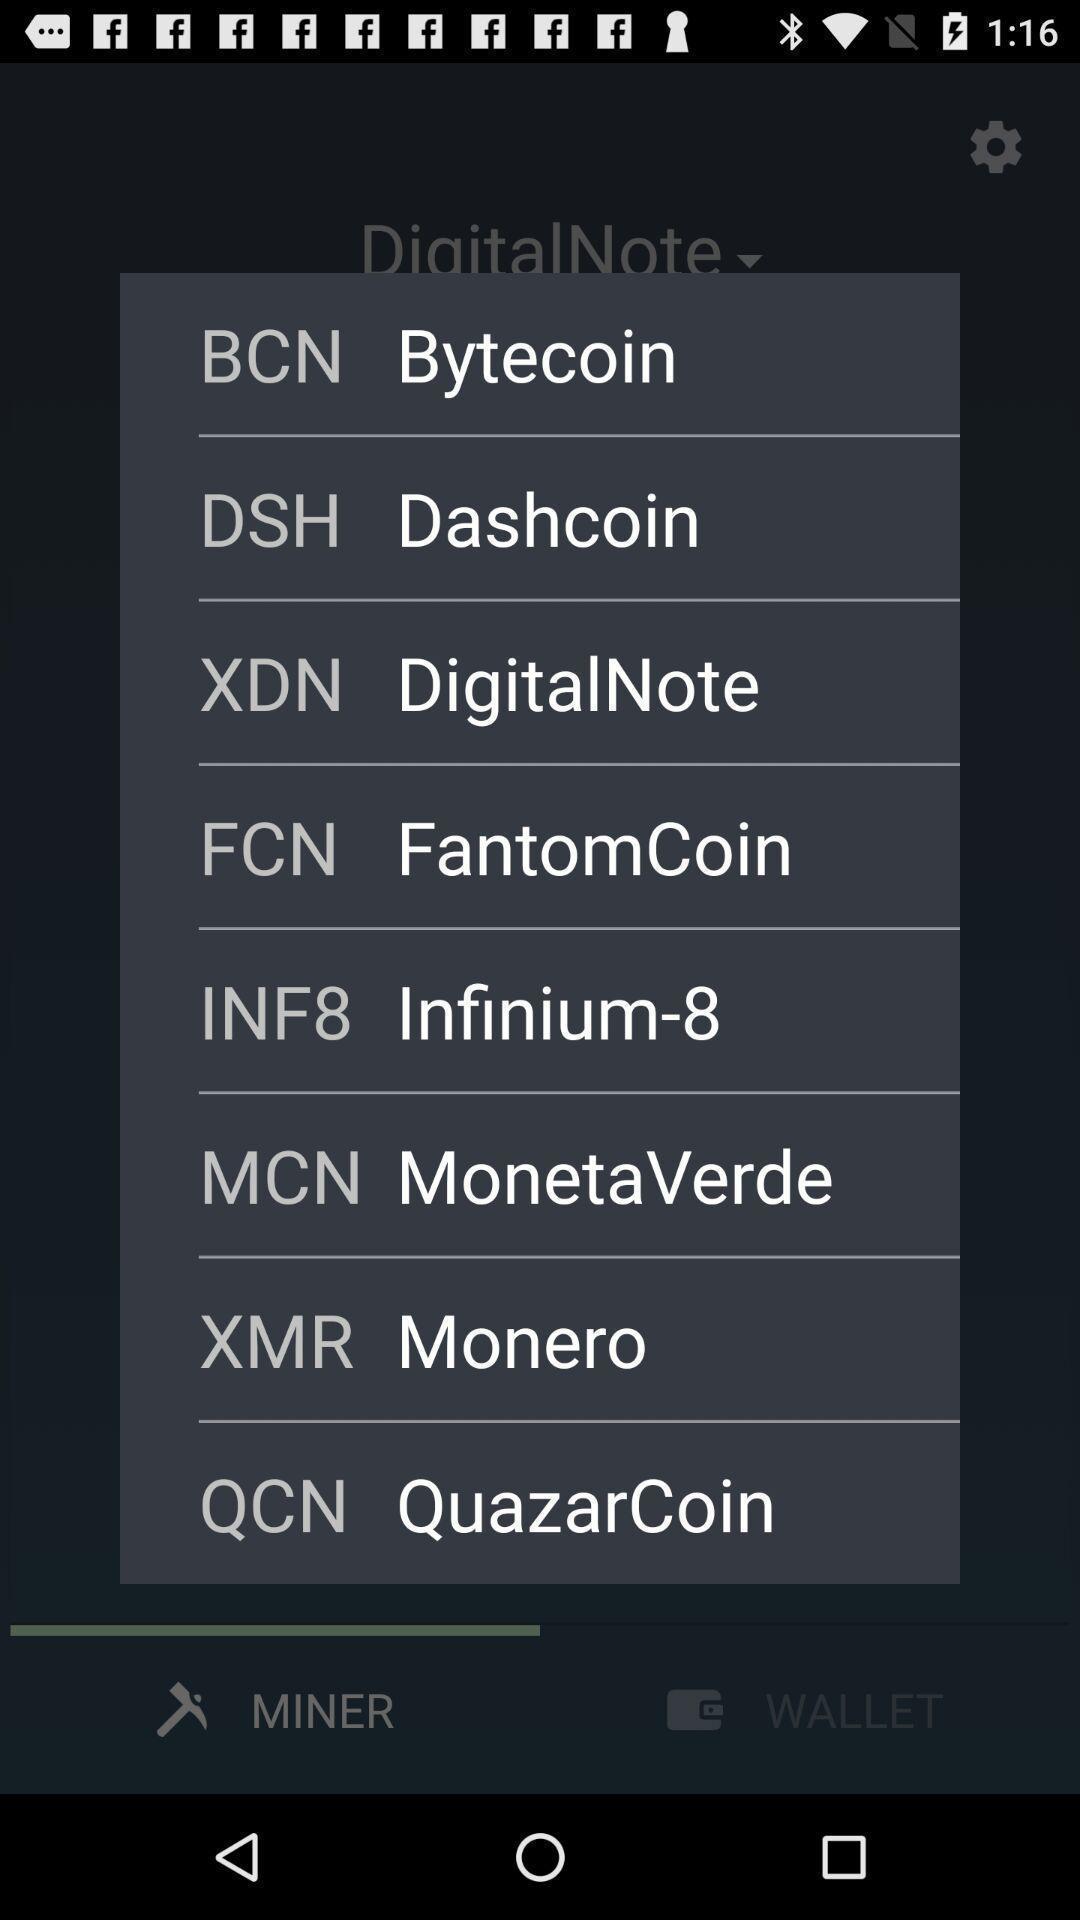Describe this image in words. Popup displaying full forms of abbreviations. 